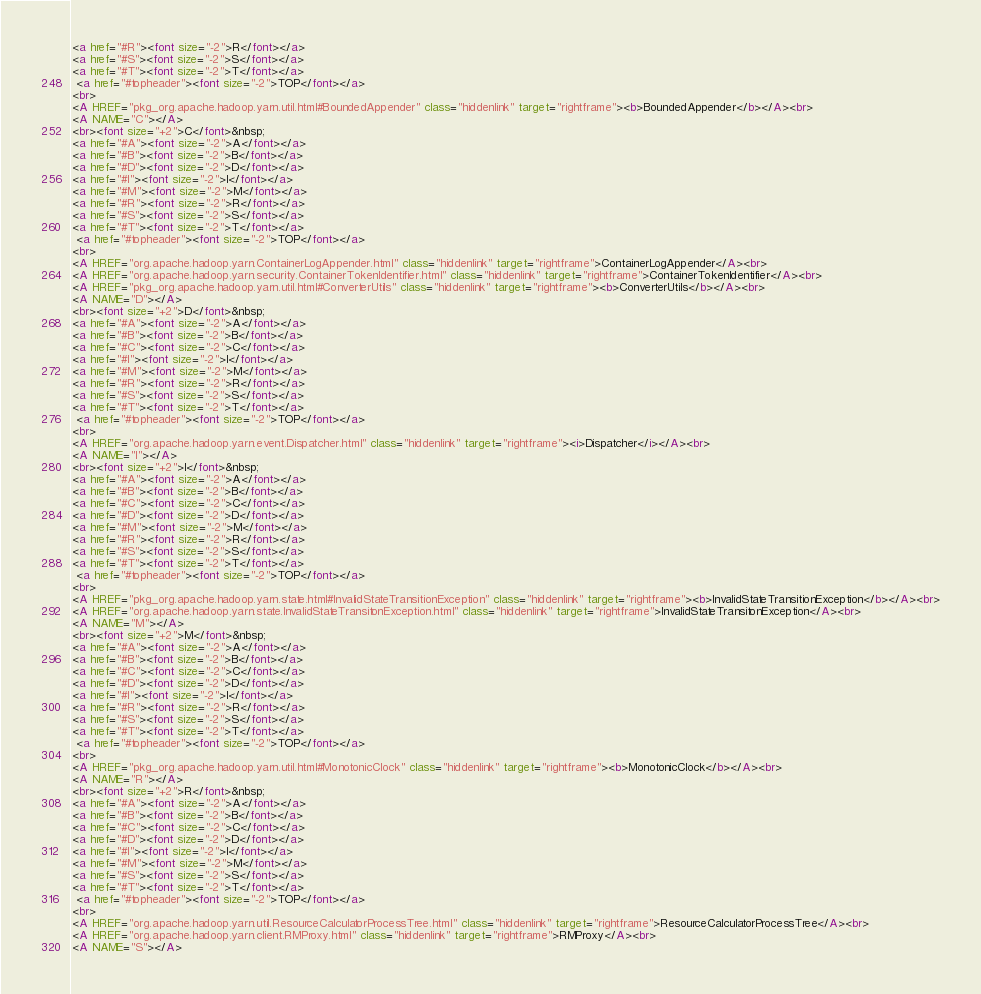Convert code to text. <code><loc_0><loc_0><loc_500><loc_500><_HTML_><a href="#R"><font size="-2">R</font></a> 
<a href="#S"><font size="-2">S</font></a> 
<a href="#T"><font size="-2">T</font></a> 
 <a href="#topheader"><font size="-2">TOP</font></a>
<br>
<A HREF="pkg_org.apache.hadoop.yarn.util.html#BoundedAppender" class="hiddenlink" target="rightframe"><b>BoundedAppender</b></A><br>
<A NAME="C"></A>
<br><font size="+2">C</font>&nbsp;
<a href="#A"><font size="-2">A</font></a> 
<a href="#B"><font size="-2">B</font></a> 
<a href="#D"><font size="-2">D</font></a> 
<a href="#I"><font size="-2">I</font></a> 
<a href="#M"><font size="-2">M</font></a> 
<a href="#R"><font size="-2">R</font></a> 
<a href="#S"><font size="-2">S</font></a> 
<a href="#T"><font size="-2">T</font></a> 
 <a href="#topheader"><font size="-2">TOP</font></a>
<br>
<A HREF="org.apache.hadoop.yarn.ContainerLogAppender.html" class="hiddenlink" target="rightframe">ContainerLogAppender</A><br>
<A HREF="org.apache.hadoop.yarn.security.ContainerTokenIdentifier.html" class="hiddenlink" target="rightframe">ContainerTokenIdentifier</A><br>
<A HREF="pkg_org.apache.hadoop.yarn.util.html#ConverterUtils" class="hiddenlink" target="rightframe"><b>ConverterUtils</b></A><br>
<A NAME="D"></A>
<br><font size="+2">D</font>&nbsp;
<a href="#A"><font size="-2">A</font></a> 
<a href="#B"><font size="-2">B</font></a> 
<a href="#C"><font size="-2">C</font></a> 
<a href="#I"><font size="-2">I</font></a> 
<a href="#M"><font size="-2">M</font></a> 
<a href="#R"><font size="-2">R</font></a> 
<a href="#S"><font size="-2">S</font></a> 
<a href="#T"><font size="-2">T</font></a> 
 <a href="#topheader"><font size="-2">TOP</font></a>
<br>
<A HREF="org.apache.hadoop.yarn.event.Dispatcher.html" class="hiddenlink" target="rightframe"><i>Dispatcher</i></A><br>
<A NAME="I"></A>
<br><font size="+2">I</font>&nbsp;
<a href="#A"><font size="-2">A</font></a> 
<a href="#B"><font size="-2">B</font></a> 
<a href="#C"><font size="-2">C</font></a> 
<a href="#D"><font size="-2">D</font></a> 
<a href="#M"><font size="-2">M</font></a> 
<a href="#R"><font size="-2">R</font></a> 
<a href="#S"><font size="-2">S</font></a> 
<a href="#T"><font size="-2">T</font></a> 
 <a href="#topheader"><font size="-2">TOP</font></a>
<br>
<A HREF="pkg_org.apache.hadoop.yarn.state.html#InvalidStateTransitionException" class="hiddenlink" target="rightframe"><b>InvalidStateTransitionException</b></A><br>
<A HREF="org.apache.hadoop.yarn.state.InvalidStateTransitonException.html" class="hiddenlink" target="rightframe">InvalidStateTransitonException</A><br>
<A NAME="M"></A>
<br><font size="+2">M</font>&nbsp;
<a href="#A"><font size="-2">A</font></a> 
<a href="#B"><font size="-2">B</font></a> 
<a href="#C"><font size="-2">C</font></a> 
<a href="#D"><font size="-2">D</font></a> 
<a href="#I"><font size="-2">I</font></a> 
<a href="#R"><font size="-2">R</font></a> 
<a href="#S"><font size="-2">S</font></a> 
<a href="#T"><font size="-2">T</font></a> 
 <a href="#topheader"><font size="-2">TOP</font></a>
<br>
<A HREF="pkg_org.apache.hadoop.yarn.util.html#MonotonicClock" class="hiddenlink" target="rightframe"><b>MonotonicClock</b></A><br>
<A NAME="R"></A>
<br><font size="+2">R</font>&nbsp;
<a href="#A"><font size="-2">A</font></a> 
<a href="#B"><font size="-2">B</font></a> 
<a href="#C"><font size="-2">C</font></a> 
<a href="#D"><font size="-2">D</font></a> 
<a href="#I"><font size="-2">I</font></a> 
<a href="#M"><font size="-2">M</font></a> 
<a href="#S"><font size="-2">S</font></a> 
<a href="#T"><font size="-2">T</font></a> 
 <a href="#topheader"><font size="-2">TOP</font></a>
<br>
<A HREF="org.apache.hadoop.yarn.util.ResourceCalculatorProcessTree.html" class="hiddenlink" target="rightframe">ResourceCalculatorProcessTree</A><br>
<A HREF="org.apache.hadoop.yarn.client.RMProxy.html" class="hiddenlink" target="rightframe">RMProxy</A><br>
<A NAME="S"></A></code> 